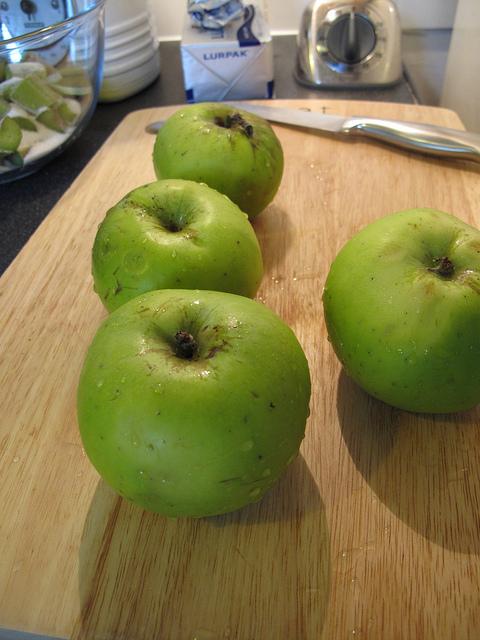What is this fruit?
Short answer required. Apple. How many apples are pictured?
Keep it brief. 4. What color are the apples?
Give a very brief answer. Green. 